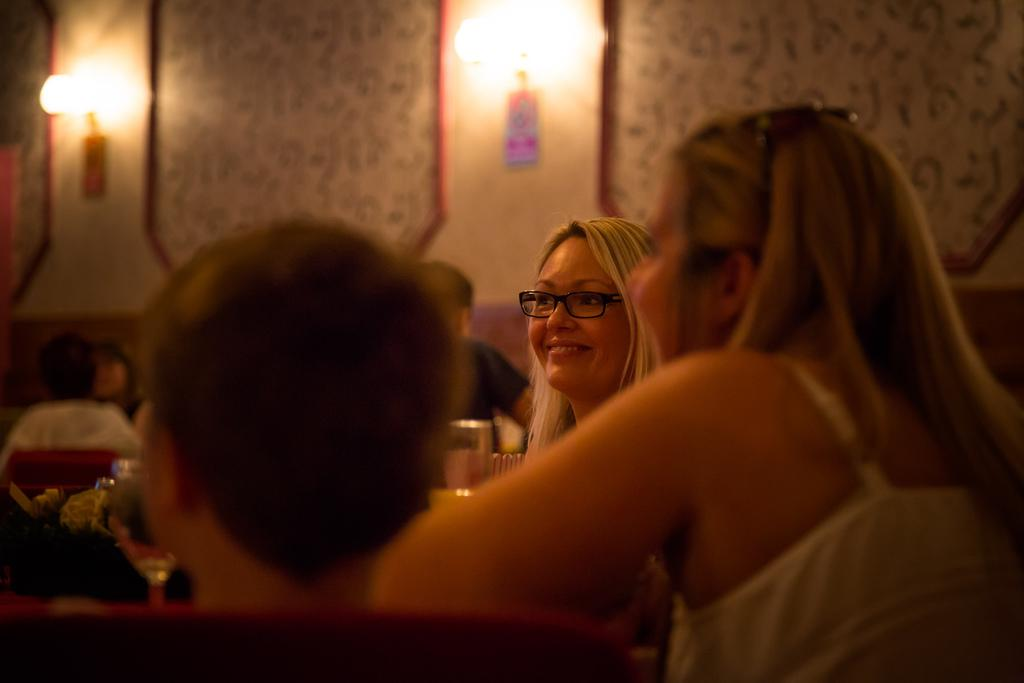Who or what is present in the image? There are people in the image. What objects can be seen in the image? There are glasses in the image. What can be seen in the background of the image? There are lights, a poster, and a wall in the background of the image. What type of lip can be seen on the poster in the image? There is no lip present on the poster in the image. 